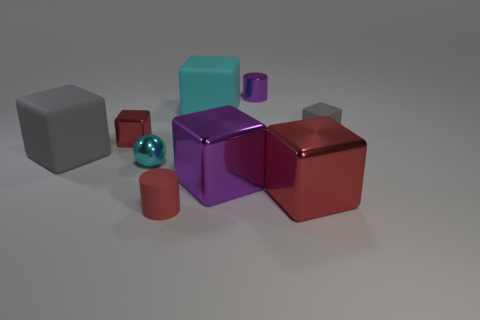Can you tell me about the colors of the objects? Certainly, the objects exhibit a variety of colors such as grey, red, purple, and teal, with variations in hues and saturation across what appear to be similar geometric forms. Do the colors of the objects signify anything in particular? Without additional context, the significance of the colors cannot be determined. They may have been chosen for aesthetic purposes or to distinguish between different materials or properties. 